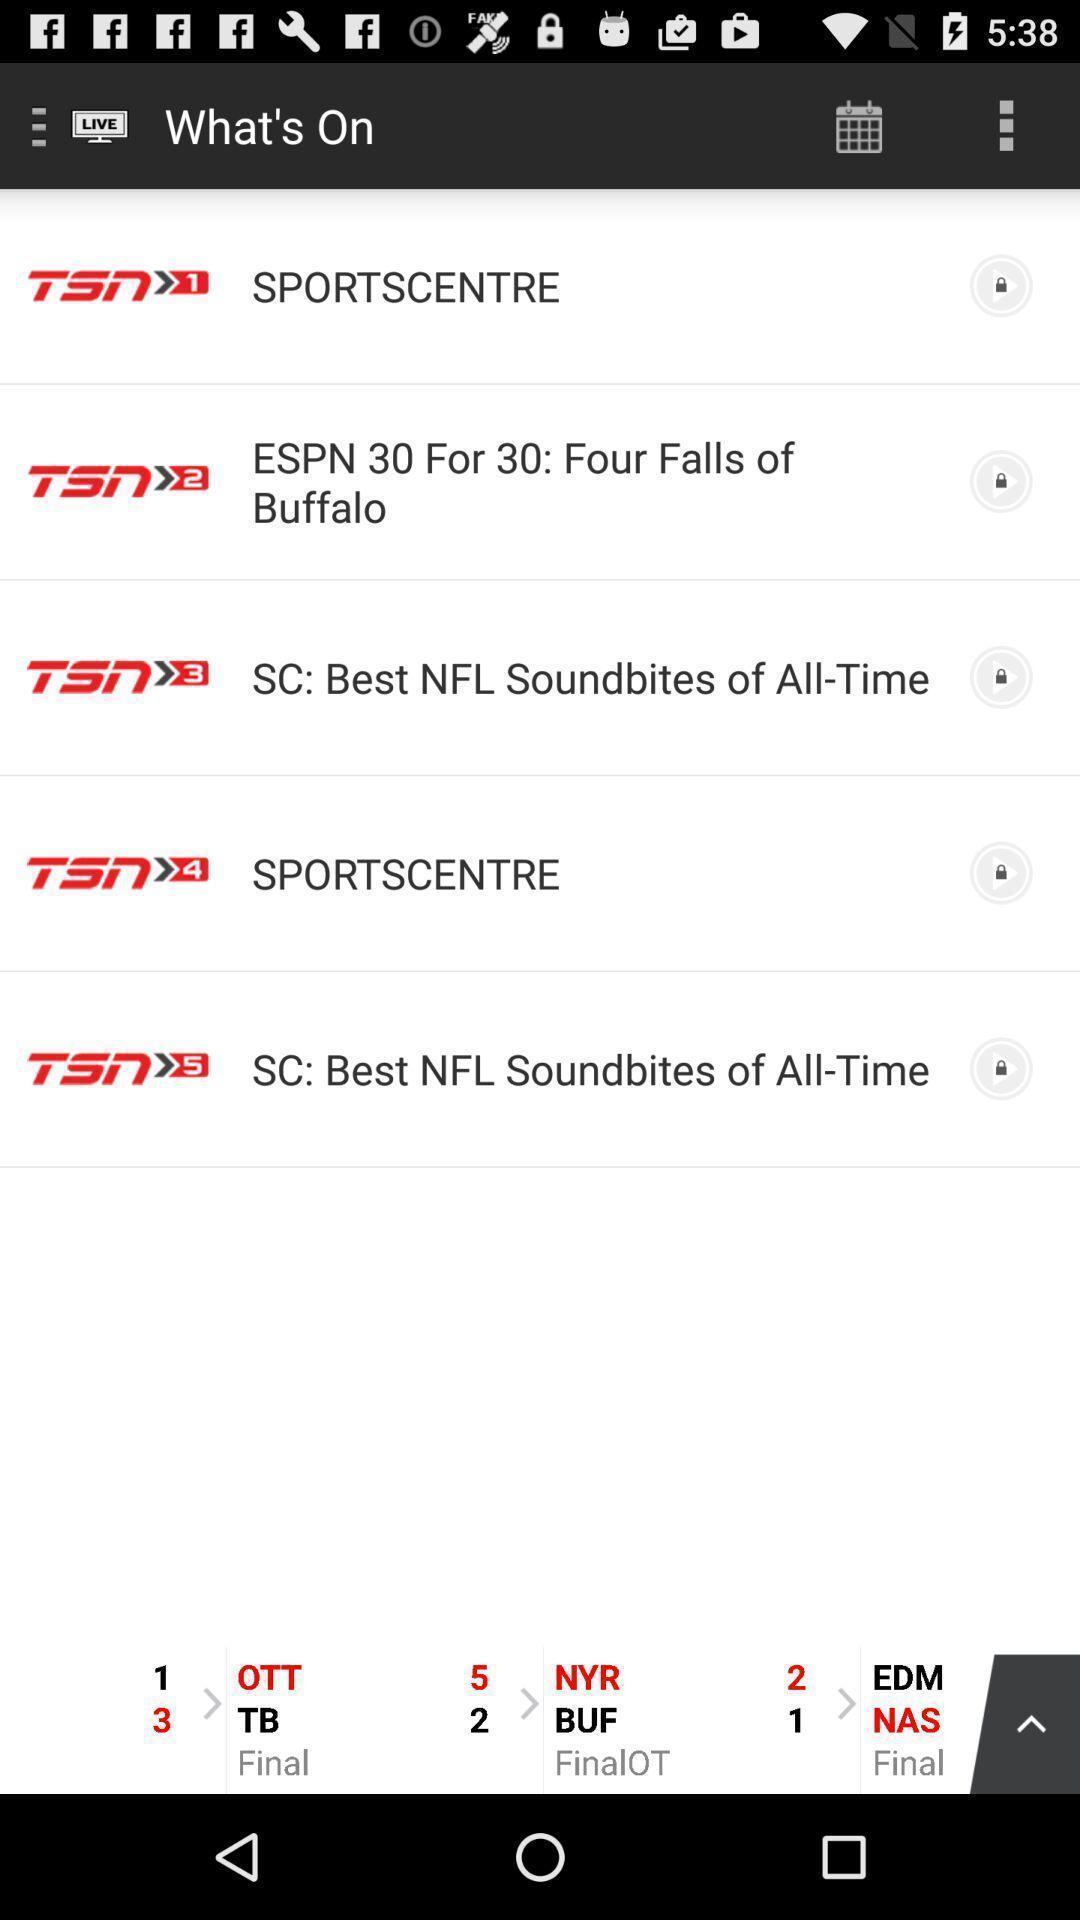Provide a description of this screenshot. Screen shows multiple options. 